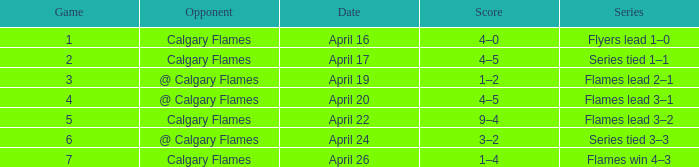Help me parse the entirety of this table. {'header': ['Game', 'Opponent', 'Date', 'Score', 'Series'], 'rows': [['1', 'Calgary Flames', 'April 16', '4–0', 'Flyers lead 1–0'], ['2', 'Calgary Flames', 'April 17', '4–5', 'Series tied 1–1'], ['3', '@ Calgary Flames', 'April 19', '1–2', 'Flames lead 2–1'], ['4', '@ Calgary Flames', 'April 20', '4–5', 'Flames lead 3–1'], ['5', 'Calgary Flames', 'April 22', '9–4', 'Flames lead 3–2'], ['6', '@ Calgary Flames', 'April 24', '3–2', 'Series tied 3–3'], ['7', 'Calgary Flames', 'April 26', '1–4', 'Flames win 4–3']]} Which Series has an Opponent of calgary flames, and a Score of 9–4? Flames lead 3–2. 